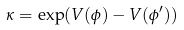Convert formula to latex. <formula><loc_0><loc_0><loc_500><loc_500>\kappa = \exp ( V ( \phi ) - V ( \phi ^ { \prime } ) )</formula> 